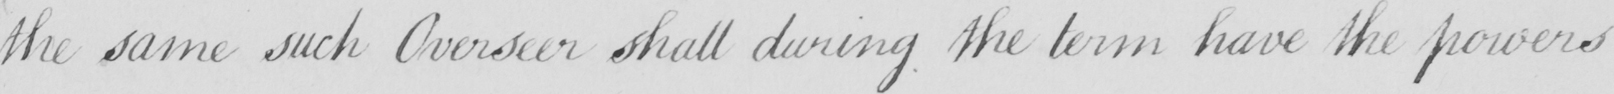Can you tell me what this handwritten text says? the same such Overseer shall during the term have the powers 